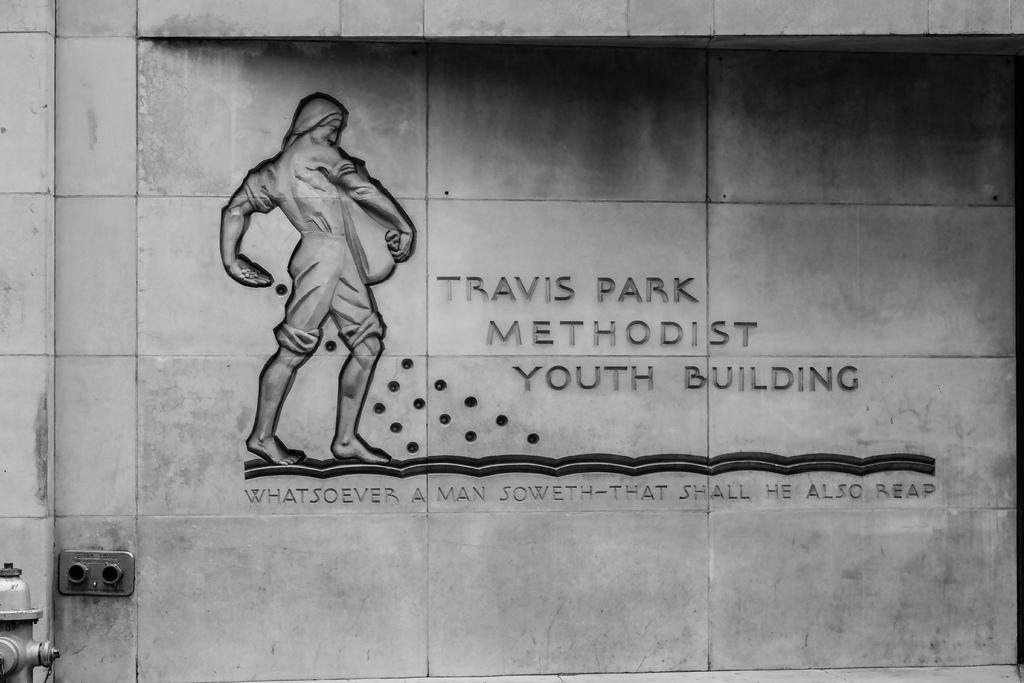What type of carving can be seen on the wall in the image? There is a human shape carving on the wall in the image. Are there any words or letters in the image? Yes, there is some text in the image. Where is the hydrant located in the image? The hydrant is in the left side bottom corner of the image. Can you describe the unspecified object in the image? Unfortunately, the facts provided do not give enough information to describe the unspecified object in the image. How many sheep are present in the image? There are no sheep present in the image. Can you describe the pies that are being sneezed out by the hydrant in the image? There are no pies or sneezing hydrants in the image. The hydrant is a stationary object, and there is no mention of pies or sneezing in the provided facts. 